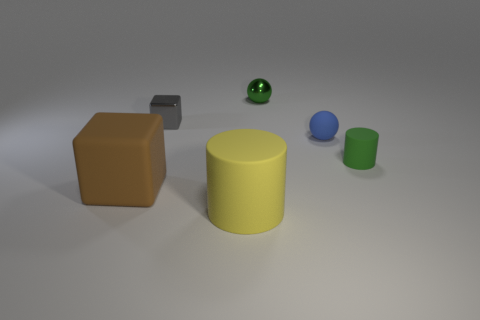Is the number of tiny gray things right of the blue matte thing greater than the number of gray metal cubes?
Your answer should be very brief. No. There is a small green shiny object that is left of the blue object; what number of rubber cylinders are behind it?
Give a very brief answer. 0. What is the shape of the green thing on the left side of the green object that is in front of the shiny object that is left of the small green sphere?
Your answer should be compact. Sphere. How big is the blue matte sphere?
Your answer should be compact. Small. Is there a big yellow cylinder made of the same material as the tiny green cylinder?
Provide a succinct answer. Yes. There is another object that is the same shape as the green metallic thing; what is its size?
Offer a very short reply. Small. Are there an equal number of big brown matte cubes that are left of the small green ball and yellow matte objects?
Your answer should be very brief. Yes. Is the shape of the green thing that is in front of the tiny rubber ball the same as  the small blue object?
Offer a terse response. No. What shape is the brown rubber thing?
Provide a short and direct response. Cube. What material is the tiny object behind the block that is behind the rubber thing that is on the left side of the large matte cylinder made of?
Give a very brief answer. Metal. 